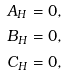Convert formula to latex. <formula><loc_0><loc_0><loc_500><loc_500>A _ { H } & = 0 , \\ B _ { H } & = 0 , \\ C _ { H } & = 0 ,</formula> 